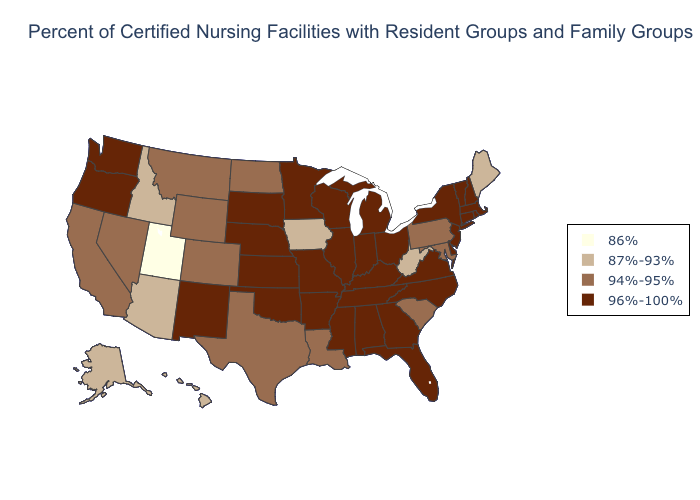Does Michigan have the lowest value in the USA?
Be succinct. No. Does the first symbol in the legend represent the smallest category?
Be succinct. Yes. Does the map have missing data?
Short answer required. No. Does Kentucky have the lowest value in the South?
Concise answer only. No. Name the states that have a value in the range 86%?
Quick response, please. Utah. Which states have the lowest value in the West?
Quick response, please. Utah. Name the states that have a value in the range 96%-100%?
Keep it brief. Alabama, Arkansas, Connecticut, Delaware, Florida, Georgia, Illinois, Indiana, Kansas, Kentucky, Massachusetts, Michigan, Minnesota, Mississippi, Missouri, Nebraska, New Hampshire, New Jersey, New Mexico, New York, North Carolina, Ohio, Oklahoma, Oregon, Rhode Island, South Dakota, Tennessee, Vermont, Virginia, Washington, Wisconsin. Name the states that have a value in the range 86%?
Keep it brief. Utah. What is the highest value in states that border Kansas?
Answer briefly. 96%-100%. What is the lowest value in the USA?
Concise answer only. 86%. What is the value of Kentucky?
Answer briefly. 96%-100%. What is the lowest value in the USA?
Concise answer only. 86%. Name the states that have a value in the range 86%?
Answer briefly. Utah. Which states have the lowest value in the USA?
Write a very short answer. Utah. Among the states that border North Dakota , does Montana have the highest value?
Short answer required. No. 